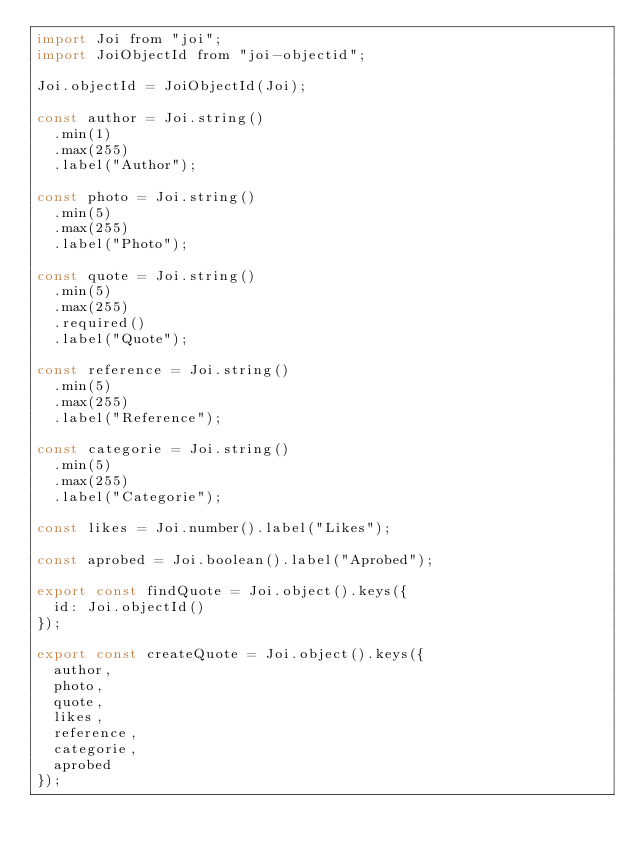<code> <loc_0><loc_0><loc_500><loc_500><_JavaScript_>import Joi from "joi";
import JoiObjectId from "joi-objectid";

Joi.objectId = JoiObjectId(Joi);

const author = Joi.string()
  .min(1)
  .max(255)
  .label("Author");

const photo = Joi.string()
  .min(5)
  .max(255)
  .label("Photo");

const quote = Joi.string()
  .min(5)
  .max(255)
  .required()
  .label("Quote");

const reference = Joi.string()
  .min(5)
  .max(255)
  .label("Reference");

const categorie = Joi.string()
  .min(5)
  .max(255)
  .label("Categorie");

const likes = Joi.number().label("Likes");

const aprobed = Joi.boolean().label("Aprobed");

export const findQuote = Joi.object().keys({
  id: Joi.objectId()
});

export const createQuote = Joi.object().keys({
  author,
  photo,
  quote,
  likes,
  reference,
  categorie,
  aprobed
});
</code> 